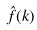<formula> <loc_0><loc_0><loc_500><loc_500>\hat { f } ( k )</formula> 